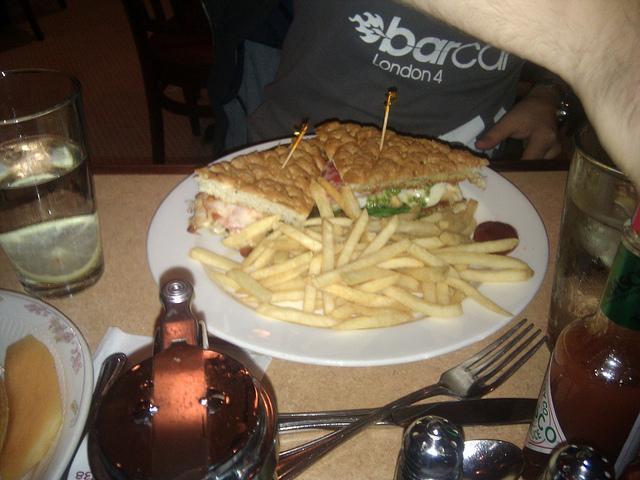Evaluate: Does the caption "The person is touching the dining table." match the image?
Answer yes or no. No. 